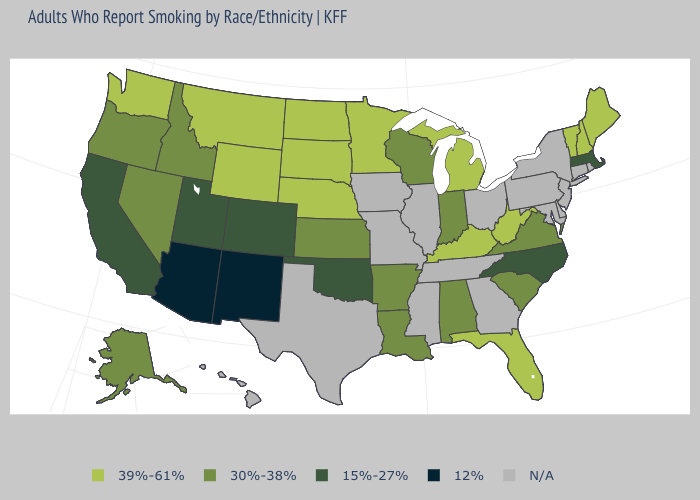What is the highest value in the USA?
Short answer required. 39%-61%. Among the states that border North Dakota , which have the highest value?
Keep it brief. Minnesota, Montana, South Dakota. Name the states that have a value in the range N/A?
Answer briefly. Connecticut, Delaware, Georgia, Hawaii, Illinois, Iowa, Maryland, Mississippi, Missouri, New Jersey, New York, Ohio, Pennsylvania, Rhode Island, Tennessee, Texas. Among the states that border Oklahoma , does New Mexico have the lowest value?
Quick response, please. Yes. What is the value of Hawaii?
Answer briefly. N/A. What is the lowest value in states that border Maryland?
Answer briefly. 30%-38%. Does Oklahoma have the lowest value in the South?
Keep it brief. Yes. Among the states that border Nevada , which have the highest value?
Short answer required. Idaho, Oregon. What is the value of Arizona?
Short answer required. 12%. Which states have the lowest value in the Northeast?
Short answer required. Massachusetts. Is the legend a continuous bar?
Short answer required. No. What is the value of Alaska?
Give a very brief answer. 30%-38%. What is the value of South Carolina?
Answer briefly. 30%-38%. Does the first symbol in the legend represent the smallest category?
Concise answer only. No. 